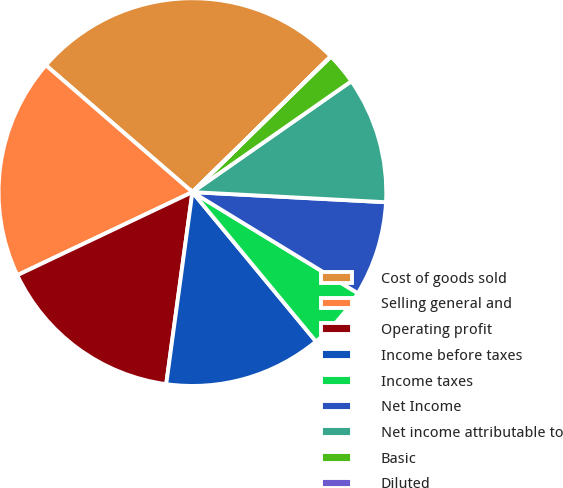<chart> <loc_0><loc_0><loc_500><loc_500><pie_chart><fcel>Cost of goods sold<fcel>Selling general and<fcel>Operating profit<fcel>Income before taxes<fcel>Income taxes<fcel>Net Income<fcel>Net income attributable to<fcel>Basic<fcel>Diluted<nl><fcel>26.3%<fcel>18.41%<fcel>15.79%<fcel>13.16%<fcel>5.27%<fcel>7.9%<fcel>10.53%<fcel>2.64%<fcel>0.01%<nl></chart> 